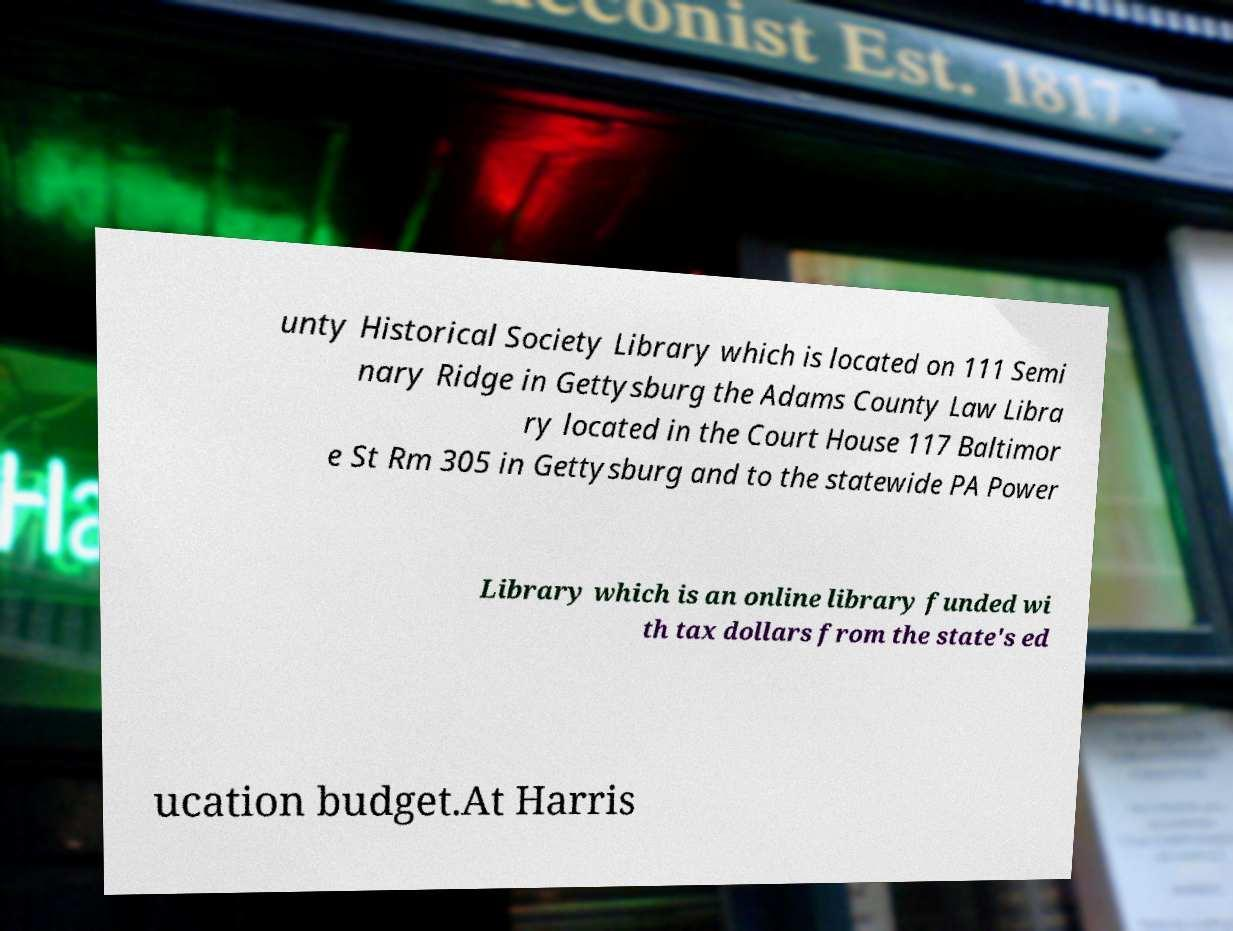Can you read and provide the text displayed in the image?This photo seems to have some interesting text. Can you extract and type it out for me? unty Historical Society Library which is located on 111 Semi nary Ridge in Gettysburg the Adams County Law Libra ry located in the Court House 117 Baltimor e St Rm 305 in Gettysburg and to the statewide PA Power Library which is an online library funded wi th tax dollars from the state's ed ucation budget.At Harris 